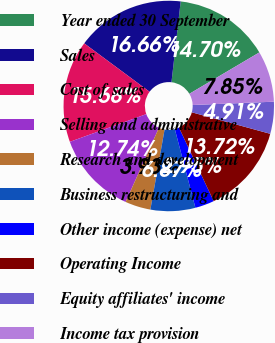Convert chart. <chart><loc_0><loc_0><loc_500><loc_500><pie_chart><fcel>Year ended 30 September<fcel>Sales<fcel>Cost of sales<fcel>Selling and administrative<fcel>Research and development<fcel>Business restructuring and<fcel>Other income (expense) net<fcel>Operating Income<fcel>Equity affiliates' income<fcel>Income tax provision<nl><fcel>14.7%<fcel>16.66%<fcel>15.68%<fcel>12.74%<fcel>3.93%<fcel>6.87%<fcel>2.95%<fcel>13.72%<fcel>4.91%<fcel>7.85%<nl></chart> 